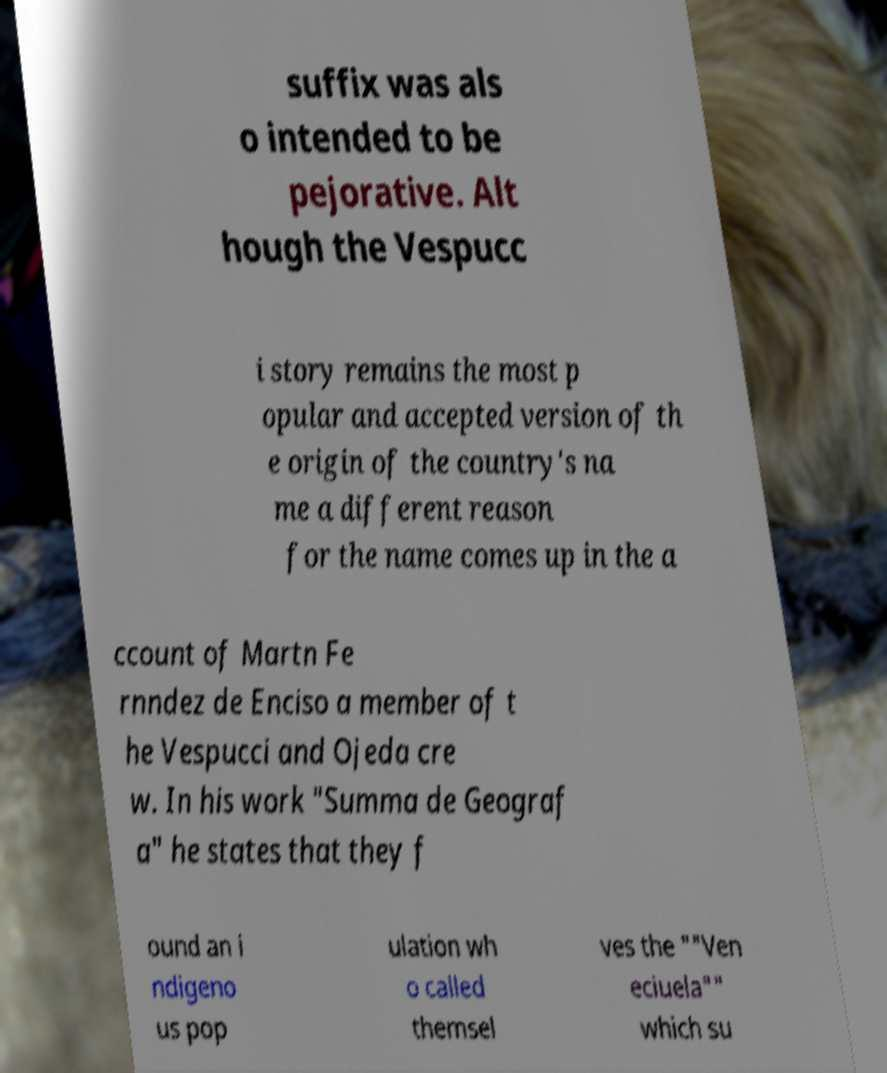There's text embedded in this image that I need extracted. Can you transcribe it verbatim? suffix was als o intended to be pejorative. Alt hough the Vespucc i story remains the most p opular and accepted version of th e origin of the country's na me a different reason for the name comes up in the a ccount of Martn Fe rnndez de Enciso a member of t he Vespucci and Ojeda cre w. In his work "Summa de Geograf a" he states that they f ound an i ndigeno us pop ulation wh o called themsel ves the ""Ven eciuela"" which su 